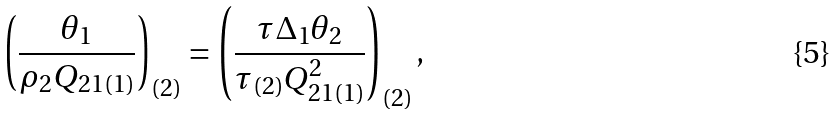Convert formula to latex. <formula><loc_0><loc_0><loc_500><loc_500>\left ( \frac { \theta _ { 1 } } { \rho _ { 2 } Q _ { 2 1 ( 1 ) } } \right ) _ { ( 2 ) } = \left ( \frac { \tau \Delta _ { 1 } \theta _ { 2 } } { \tau _ { ( 2 ) } Q _ { 2 1 ( 1 ) } ^ { 2 } } \right ) _ { ( 2 ) } ,</formula> 